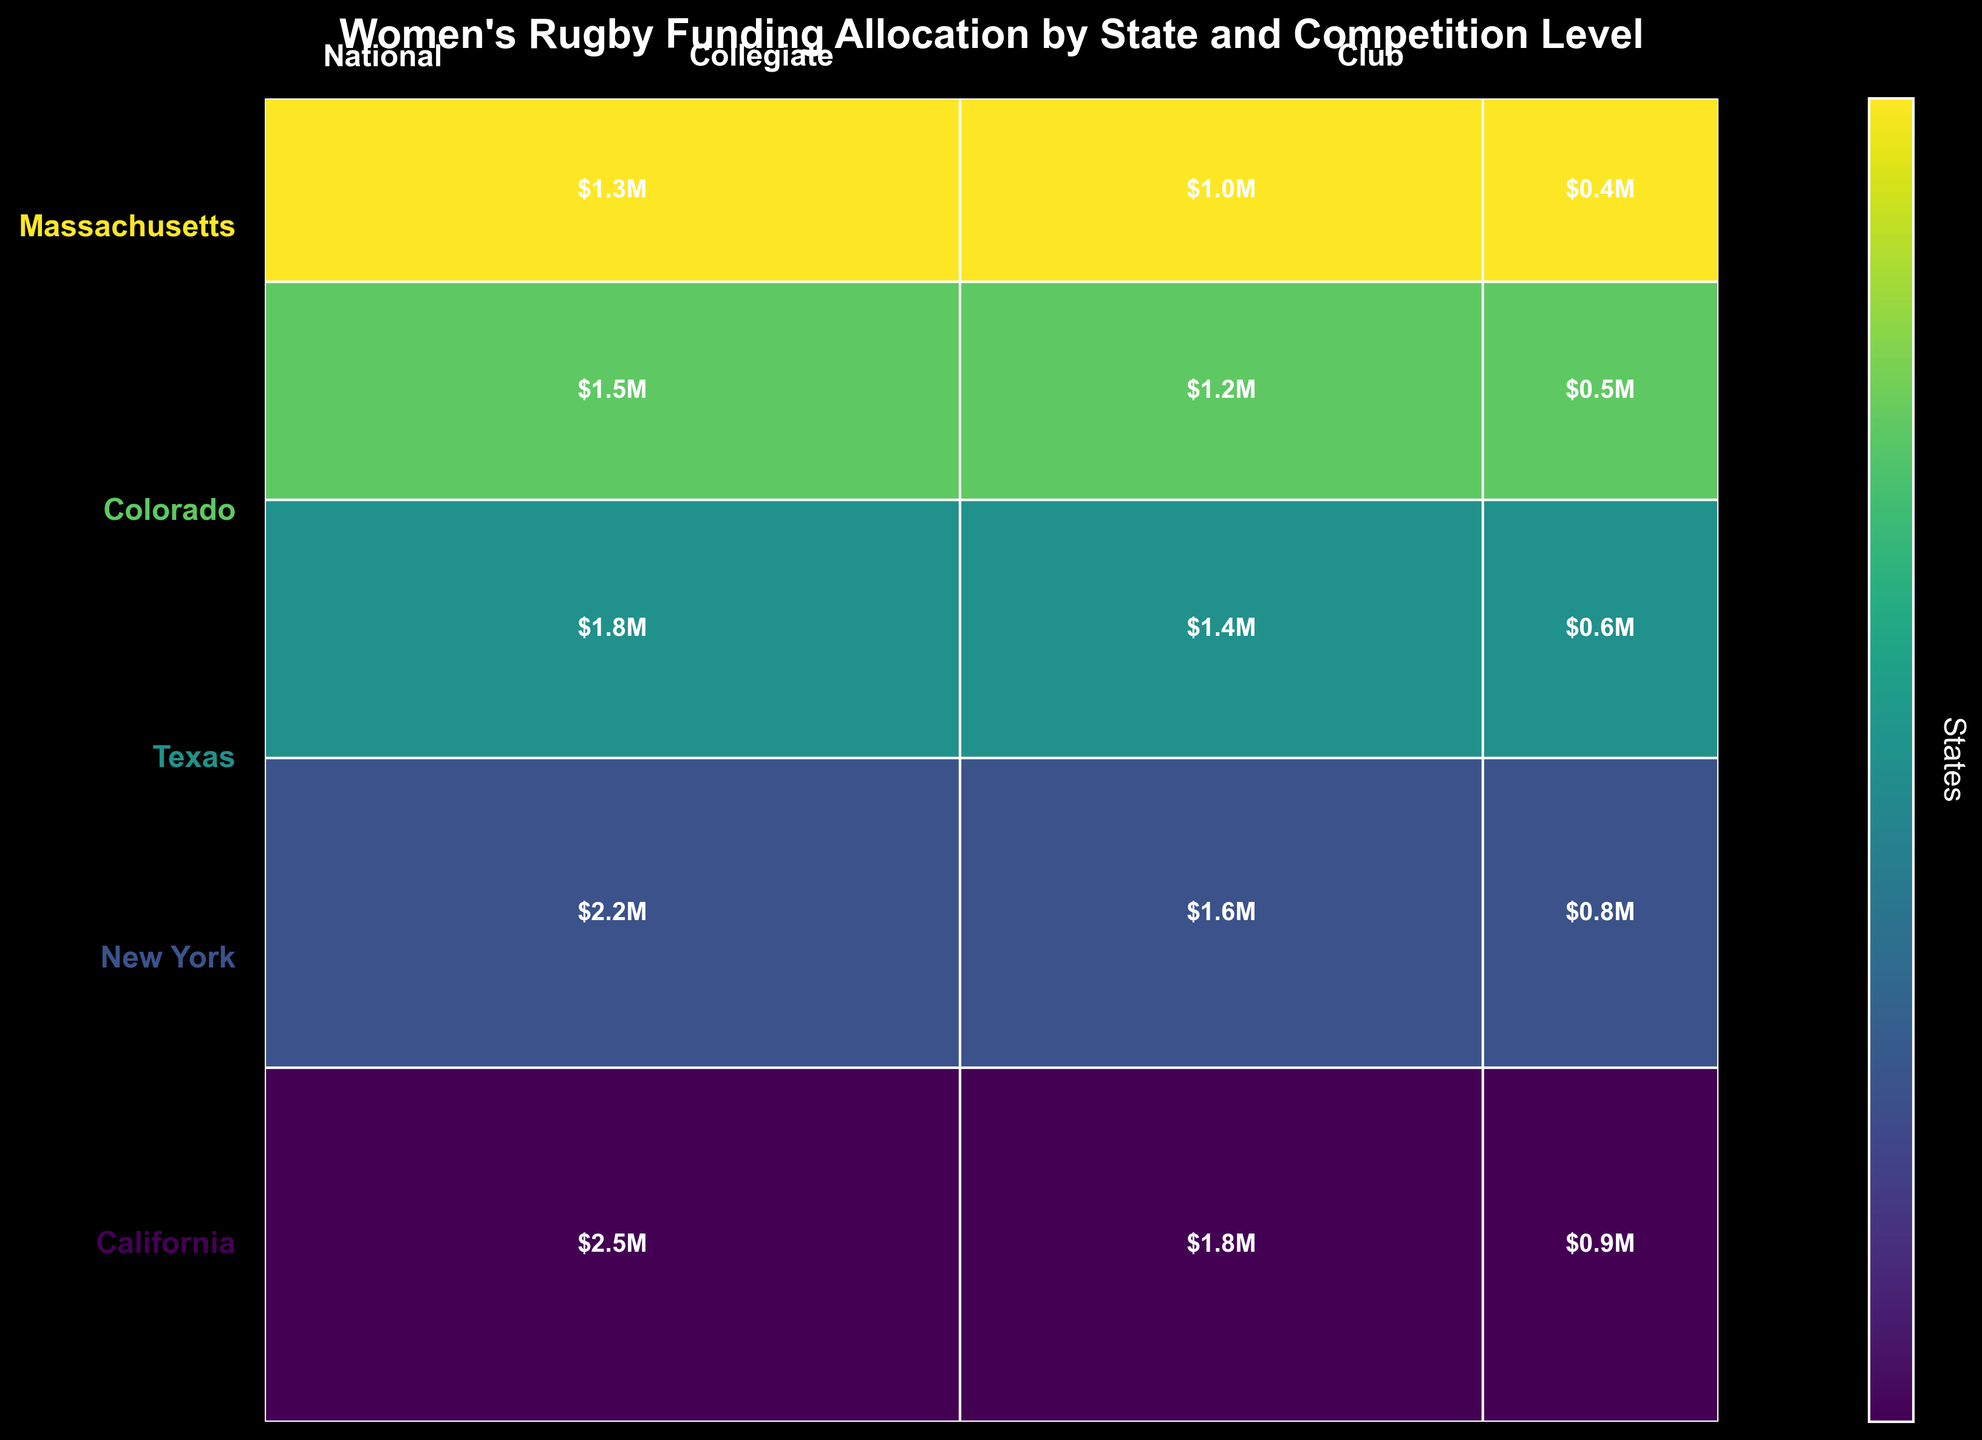What is the title of the figure? The title is usually displayed at the top of the plot. It is a textual description of what the figure is about.
Answer: Women's Rugby Funding Allocation by State and Competition Level How many states are represented in the plot? Each unique state has its name annotated on the y-axis on the left side of the plot. Count each of these unique labels.
Answer: 5 Which state has the highest total funding allocation? Find the state region with the largest proportion on the plot and check the corresponding state name.
Answer: California What is the color of the highest funding allocation category in the plot? The color represents different states in the plot. The largest rectangle pertains to California, colored as specified by the colormap (some shade from the 'viridis' color palette).
Answer: The darkest shade (typically at the top end of the 'viridis' palette) Which competition level receives the most funding in New York? Look at the proportion of different competition levels within the New York segment and find the highest funded segment.
Answer: National What is the total amount of funding allocated to Texas? Sum the funding for all competition levels in Texas as represented by the Texas section.
Answer: $3.4M What is the funding difference between National and Club levels in Massachusetts? Identify the funding allocations for the National and Club competition levels in Massachusetts and take their difference ($1300000 - $400000).
Answer: $900,000 How does California's funding for the Collegiate level compare to Colorado's total funding allocation? Compare California's collegiate funding allocation with the sum of all funding levels for Colorado (California Collegiate: $1800000, Colorado Total: $3200000).
Answer: Less Which state shows similar funding amounts between Collegiate and National levels? Look for a state where the rectangle heights for Collegiate and National levels are almost equal.
Answer: Massachusetts Compare the combined funding for Club levels in Colorado and Massachusetts to Texas's National level allocation. Which is greater? Sum the Club level funding for Colorado and Massachusetts ($500000 + $400000 = $900000) and compare it to Texas's National level funding ($1800000).
Answer: Texas's National level allocation is greater 